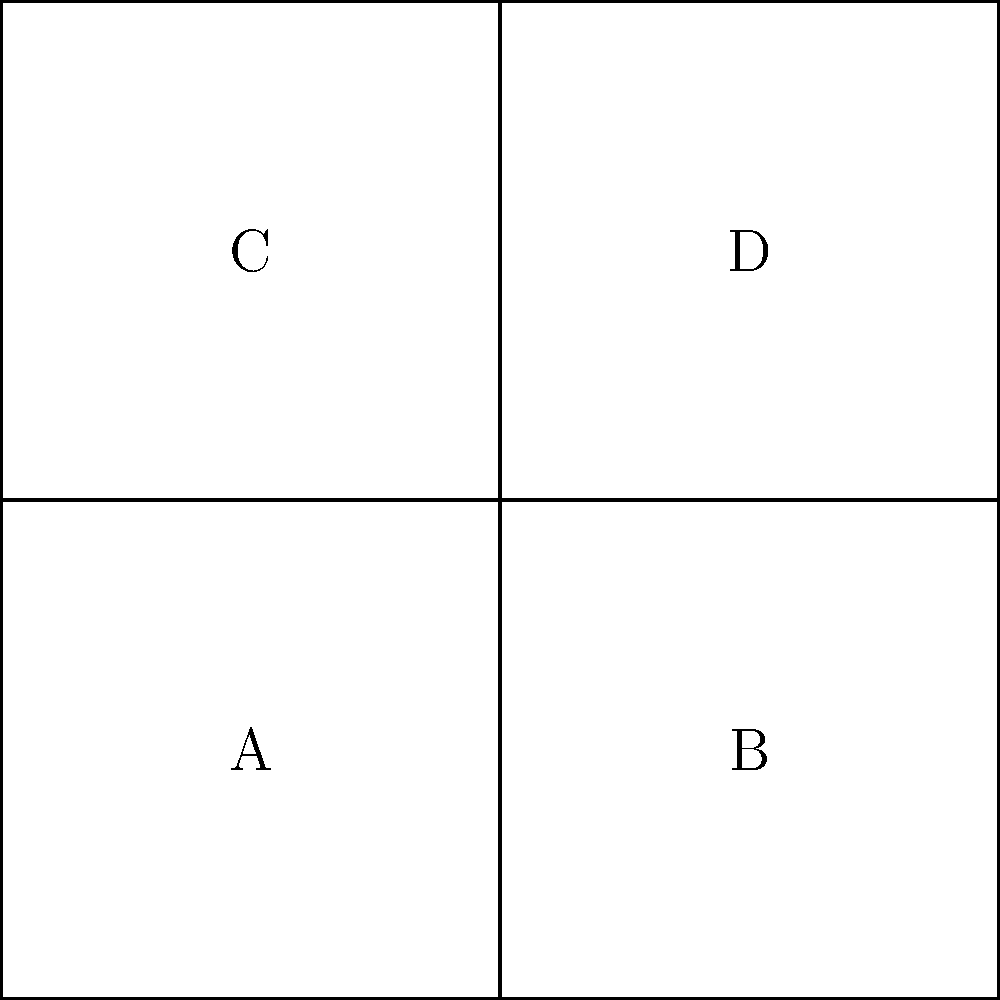Given the 2D technical diagram above representing an unfolded cube, which face will be opposite to face A when the cube is folded? To determine which face will be opposite to face A when the cube is folded, let's follow these steps:

1. Identify the central face: Face A is the central face in the unfolded diagram.

2. Analyze the adjacent faces:
   - Face B is to the right of A
   - Face C is above A
   - Face D is diagonally adjacent to A

3. Visualize the folding process:
   - B will fold to form the right face of the cube
   - C will fold to form the top face of the cube
   - D will fold to form the back face of the cube

4. Deduce the opposite face:
   - In a cube, the opposite face is the one that's not adjacent to the reference face
   - Faces A, B, and C are all connected in the 2D diagram
   - Face D is the only face not directly connected to A in the 2D diagram

5. Conclude:
   When the cube is folded, face D will be on the opposite side of face A.
Answer: D 